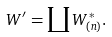<formula> <loc_0><loc_0><loc_500><loc_500>W ^ { \prime } = \coprod W _ { ( n ) } ^ { * } .</formula> 